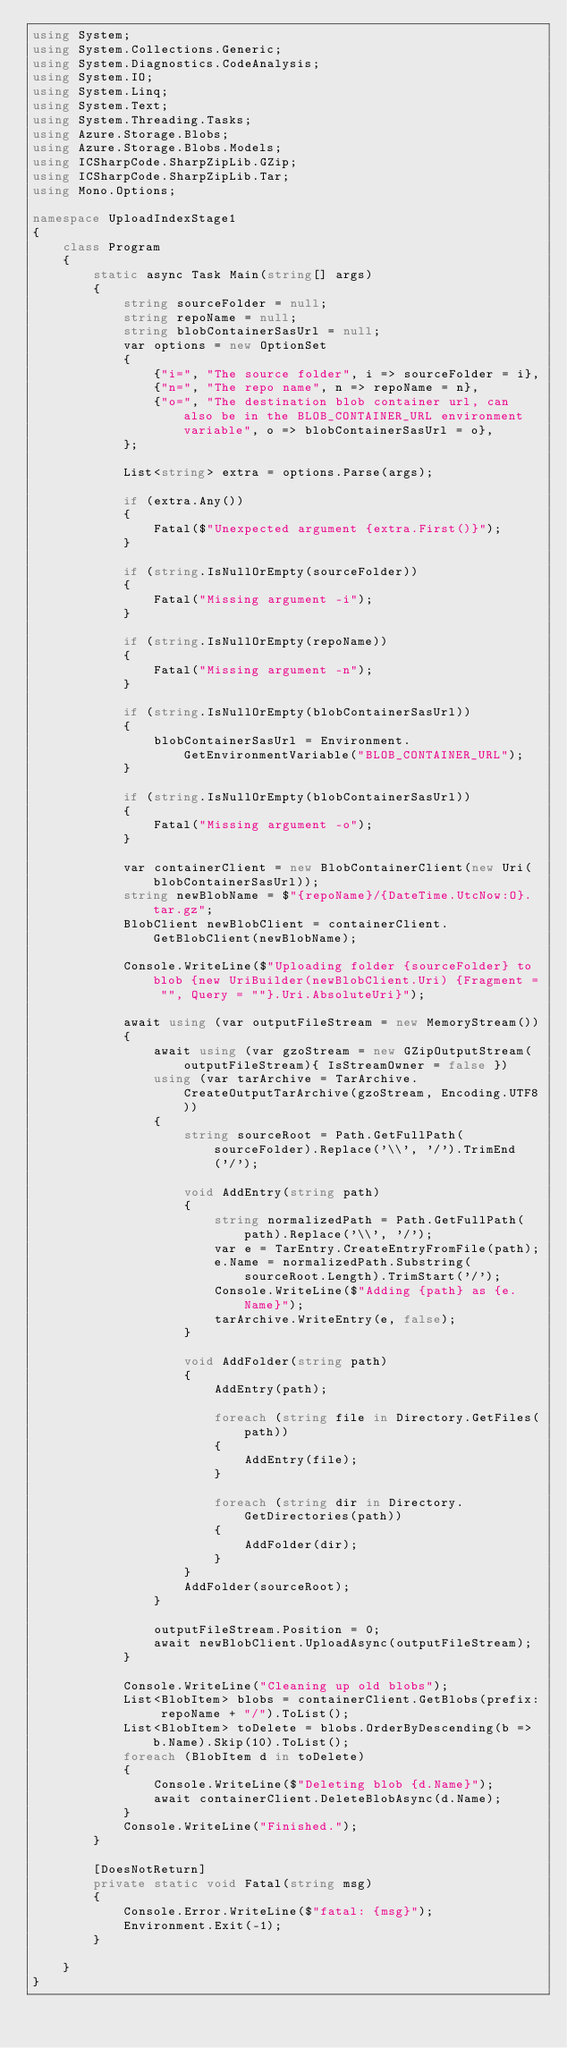<code> <loc_0><loc_0><loc_500><loc_500><_C#_>using System;
using System.Collections.Generic;
using System.Diagnostics.CodeAnalysis;
using System.IO;
using System.Linq;
using System.Text;
using System.Threading.Tasks;
using Azure.Storage.Blobs;
using Azure.Storage.Blobs.Models;
using ICSharpCode.SharpZipLib.GZip;
using ICSharpCode.SharpZipLib.Tar;
using Mono.Options;

namespace UploadIndexStage1
{
    class Program
    {
        static async Task Main(string[] args)
        {
            string sourceFolder = null;
            string repoName = null;
            string blobContainerSasUrl = null;
            var options = new OptionSet
            {
                {"i=", "The source folder", i => sourceFolder = i},
                {"n=", "The repo name", n => repoName = n},
                {"o=", "The destination blob container url, can also be in the BLOB_CONTAINER_URL environment variable", o => blobContainerSasUrl = o},
            };

            List<string> extra = options.Parse(args);

            if (extra.Any())
            {
                Fatal($"Unexpected argument {extra.First()}");
            }

            if (string.IsNullOrEmpty(sourceFolder))
            {
                Fatal("Missing argument -i");
            }

            if (string.IsNullOrEmpty(repoName))
            {
                Fatal("Missing argument -n");
            }

            if (string.IsNullOrEmpty(blobContainerSasUrl))
            {
                blobContainerSasUrl = Environment.GetEnvironmentVariable("BLOB_CONTAINER_URL");
            }

            if (string.IsNullOrEmpty(blobContainerSasUrl))
            {
                Fatal("Missing argument -o");
            }

            var containerClient = new BlobContainerClient(new Uri(blobContainerSasUrl));
            string newBlobName = $"{repoName}/{DateTime.UtcNow:O}.tar.gz";
            BlobClient newBlobClient = containerClient.GetBlobClient(newBlobName);

            Console.WriteLine($"Uploading folder {sourceFolder} to blob {new UriBuilder(newBlobClient.Uri) {Fragment = "", Query = ""}.Uri.AbsoluteUri}");

            await using (var outputFileStream = new MemoryStream())
            {
                await using (var gzoStream = new GZipOutputStream(outputFileStream){ IsStreamOwner = false })
                using (var tarArchive = TarArchive.CreateOutputTarArchive(gzoStream, Encoding.UTF8))
                {
                    string sourceRoot = Path.GetFullPath(sourceFolder).Replace('\\', '/').TrimEnd('/');

                    void AddEntry(string path)
                    {
                        string normalizedPath = Path.GetFullPath(path).Replace('\\', '/');
                        var e = TarEntry.CreateEntryFromFile(path);
                        e.Name = normalizedPath.Substring(sourceRoot.Length).TrimStart('/');
                        Console.WriteLine($"Adding {path} as {e.Name}");
                        tarArchive.WriteEntry(e, false);
                    }

                    void AddFolder(string path)
                    {
                        AddEntry(path);

                        foreach (string file in Directory.GetFiles(path))
                        {
                            AddEntry(file);
                        }

                        foreach (string dir in Directory.GetDirectories(path))
                        {
                            AddFolder(dir);
                        }
                    }
                    AddFolder(sourceRoot);
                }

                outputFileStream.Position = 0;
                await newBlobClient.UploadAsync(outputFileStream);
            }

            Console.WriteLine("Cleaning up old blobs");
            List<BlobItem> blobs = containerClient.GetBlobs(prefix: repoName + "/").ToList();
            List<BlobItem> toDelete = blobs.OrderByDescending(b => b.Name).Skip(10).ToList();
            foreach (BlobItem d in toDelete)
            {
                Console.WriteLine($"Deleting blob {d.Name}");
                await containerClient.DeleteBlobAsync(d.Name);
            }
            Console.WriteLine("Finished.");
        }

        [DoesNotReturn]
        private static void Fatal(string msg)
        {
            Console.Error.WriteLine($"fatal: {msg}");
            Environment.Exit(-1);
        }

    }
}
</code> 